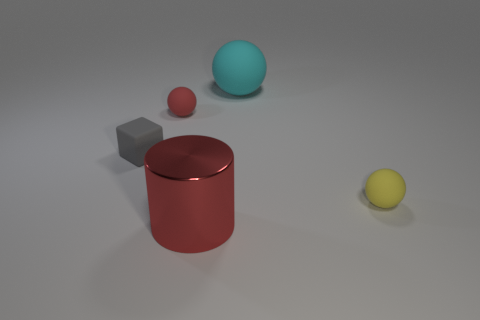Is the material of the red object behind the cylinder the same as the object behind the red rubber sphere?
Your answer should be compact. Yes. Is there any other thing that is the same material as the cyan thing?
Offer a very short reply. Yes. There is a tiny rubber object that is on the right side of the red rubber ball; does it have the same shape as the tiny rubber object that is behind the block?
Make the answer very short. Yes. Are there fewer small balls to the right of the big shiny object than yellow matte spheres?
Your answer should be very brief. No. How many tiny matte spheres are the same color as the metal object?
Keep it short and to the point. 1. There is a red object that is behind the big shiny thing; what size is it?
Your answer should be compact. Small. What is the shape of the large cyan thing that is right of the sphere left of the big thing behind the gray cube?
Your answer should be very brief. Sphere. There is a rubber object that is right of the large red cylinder and in front of the large matte object; what is its shape?
Ensure brevity in your answer.  Sphere. Are there any cyan balls that have the same size as the gray thing?
Make the answer very short. No. Does the tiny rubber object that is right of the small red rubber thing have the same shape as the gray matte thing?
Ensure brevity in your answer.  No. 